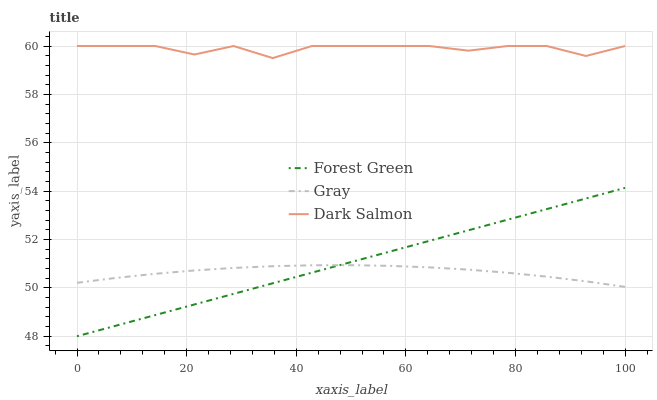Does Forest Green have the minimum area under the curve?
Answer yes or no. No. Does Forest Green have the maximum area under the curve?
Answer yes or no. No. Is Dark Salmon the smoothest?
Answer yes or no. No. Is Forest Green the roughest?
Answer yes or no. No. Does Dark Salmon have the lowest value?
Answer yes or no. No. Does Forest Green have the highest value?
Answer yes or no. No. Is Forest Green less than Dark Salmon?
Answer yes or no. Yes. Is Dark Salmon greater than Forest Green?
Answer yes or no. Yes. Does Forest Green intersect Dark Salmon?
Answer yes or no. No. 